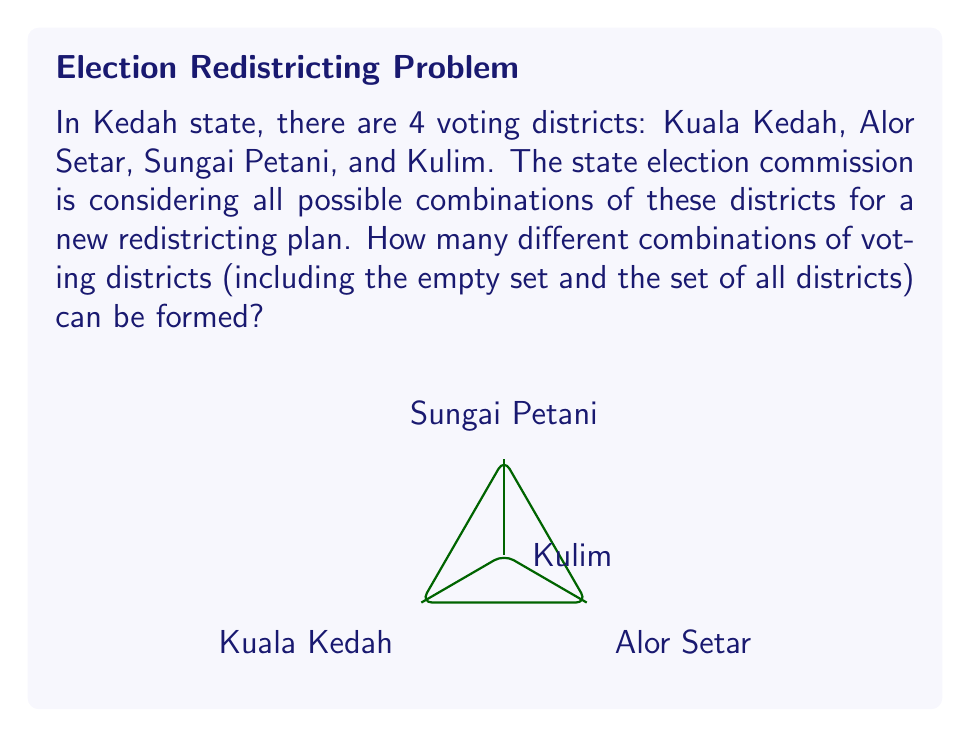Show me your answer to this math problem. To solve this problem, we need to apply the concept of power sets. The power set of a set S is the set of all subsets of S, including the empty set and S itself.

Let's approach this step-by-step:

1) First, let's define our set of voting districts:
   $S = \{\text{Kuala Kedah, Alor Setar, Sungai Petani, Kulim}\}$

2) The number of elements in set S is 4.

3) For a set with n elements, the number of elements in its power set is given by the formula:
   $2^n$

4) In this case, $n = 4$, so the number of elements in the power set is:
   $2^4 = 16$

5) We can verify this by listing out all possible combinations:
   - Empty set: $\{\}$
   - Single district sets: $\{\text{Kuala Kedah}\}$, $\{\text{Alor Setar}\}$, $\{\text{Sungai Petani}\}$, $\{\text{Kulim}\}$
   - Two district sets: $\{\text{Kuala Kedah, Alor Setar}\}$, $\{\text{Kuala Kedah, Sungai Petani}\}$, $\{\text{Kuala Kedah, Kulim}\}$, $\{\text{Alor Setar, Sungai Petani}\}$, $\{\text{Alor Setar, Kulim}\}$, $\{\text{Sungai Petani, Kulim}\}$
   - Three district sets: $\{\text{Kuala Kedah, Alor Setar, Sungai Petani}\}$, $\{\text{Kuala Kedah, Alor Setar, Kulim}\}$, $\{\text{Kuala Kedah, Sungai Petani, Kulim}\}$, $\{\text{Alor Setar, Sungai Petani, Kulim}\}$
   - Full set: $\{\text{Kuala Kedah, Alor Setar, Sungai Petani, Kulim}\}$

Therefore, there are 16 different combinations of voting districts that can be formed.
Answer: 16 